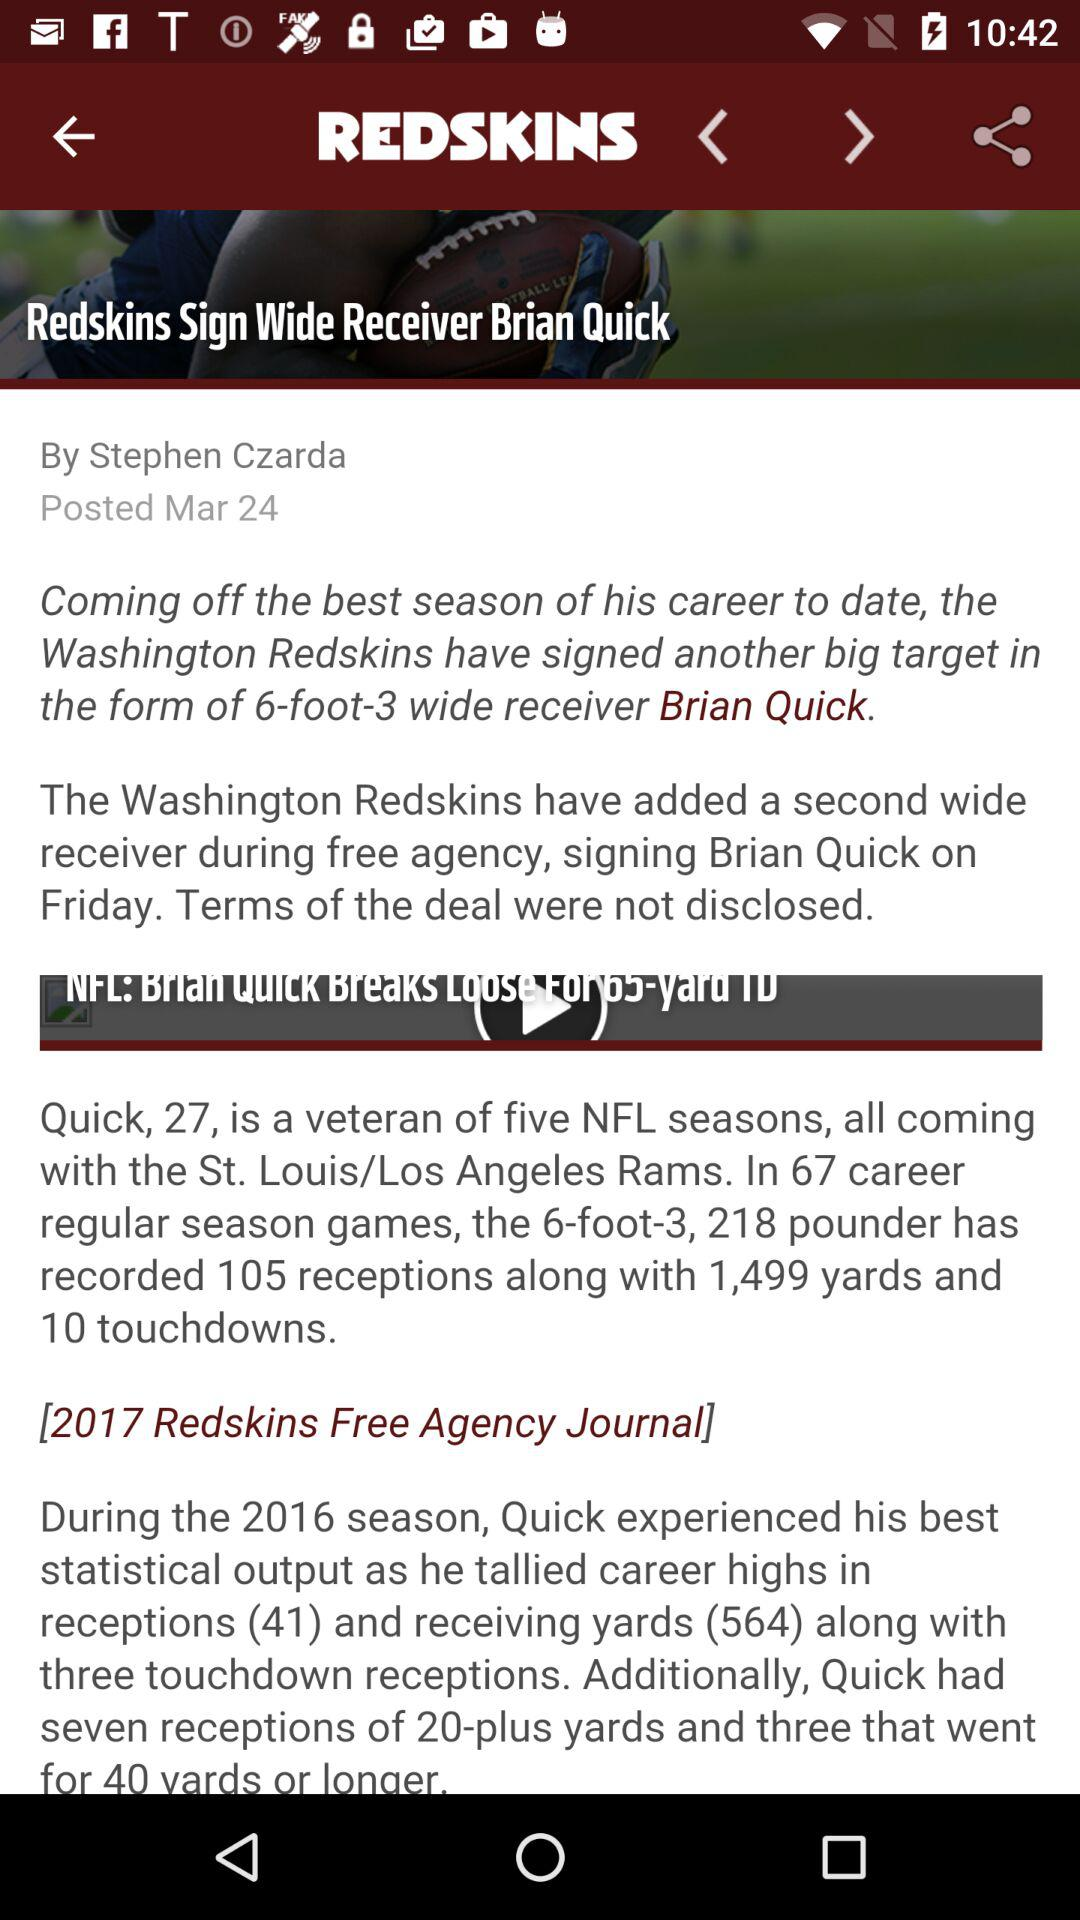When was the news about "Redskins Sign Wide Receiver Brian Quick" posted? The news about "Redskins Sign Wide Receiver Brian Quick" was posted on March 24. 